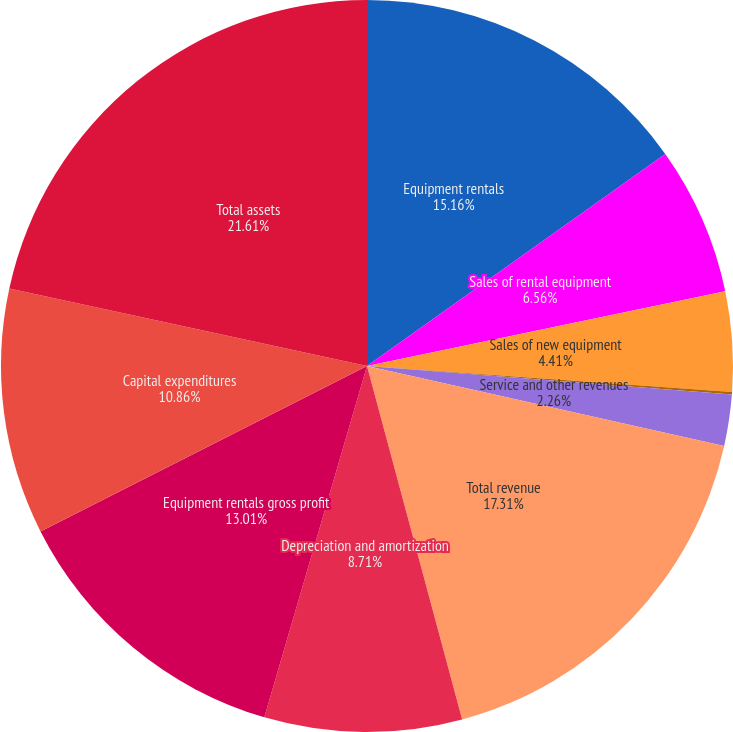Convert chart. <chart><loc_0><loc_0><loc_500><loc_500><pie_chart><fcel>Equipment rentals<fcel>Sales of rental equipment<fcel>Sales of new equipment<fcel>Contractor supplies sales<fcel>Service and other revenues<fcel>Total revenue<fcel>Depreciation and amortization<fcel>Equipment rentals gross profit<fcel>Capital expenditures<fcel>Total assets<nl><fcel>15.16%<fcel>6.56%<fcel>4.41%<fcel>0.11%<fcel>2.26%<fcel>17.31%<fcel>8.71%<fcel>13.01%<fcel>10.86%<fcel>21.6%<nl></chart> 